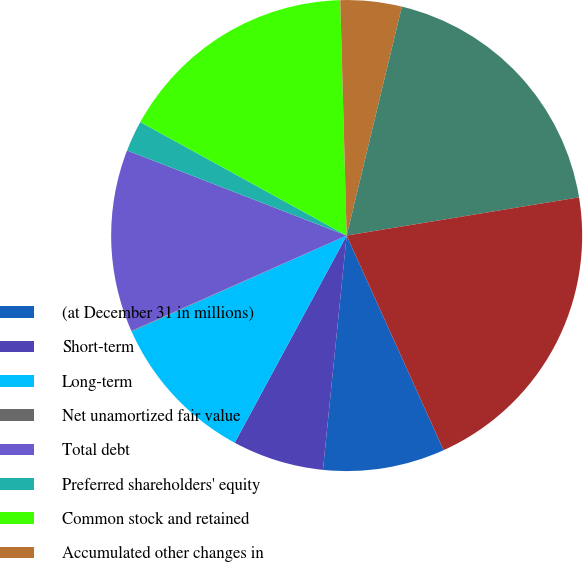Convert chart. <chart><loc_0><loc_0><loc_500><loc_500><pie_chart><fcel>(at December 31 in millions)<fcel>Short-term<fcel>Long-term<fcel>Net unamortized fair value<fcel>Total debt<fcel>Preferred shareholders' equity<fcel>Common stock and retained<fcel>Accumulated other changes in<fcel>Total shareholders' equity<fcel>Total capitalization<nl><fcel>8.36%<fcel>6.28%<fcel>10.44%<fcel>0.04%<fcel>12.52%<fcel>2.12%<fcel>16.56%<fcel>4.2%<fcel>18.64%<fcel>20.84%<nl></chart> 